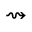Convert formula to latex. <formula><loc_0><loc_0><loc_500><loc_500>\right s q u i g a r r o w</formula> 